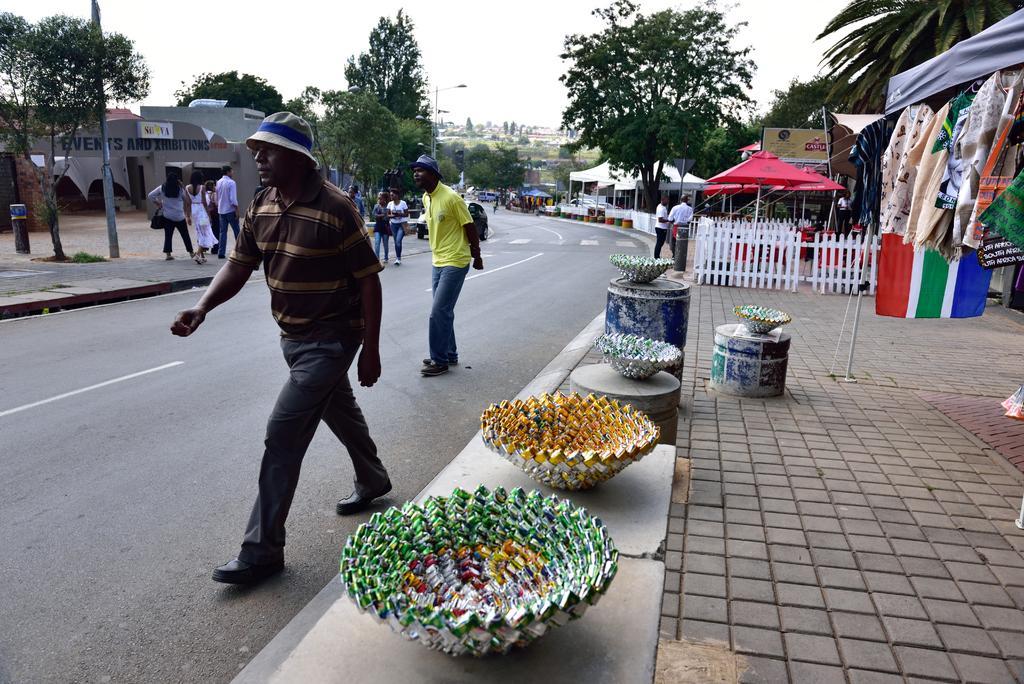Could you give a brief overview of what you see in this image? In this image we can see there is a group of people walking on the road, on the right side of the road, there are trees, stores, objects which look like bowels are placed on a surface, tents, railings, boards and people, on the left side of the road there are houses, a few people and trees. 